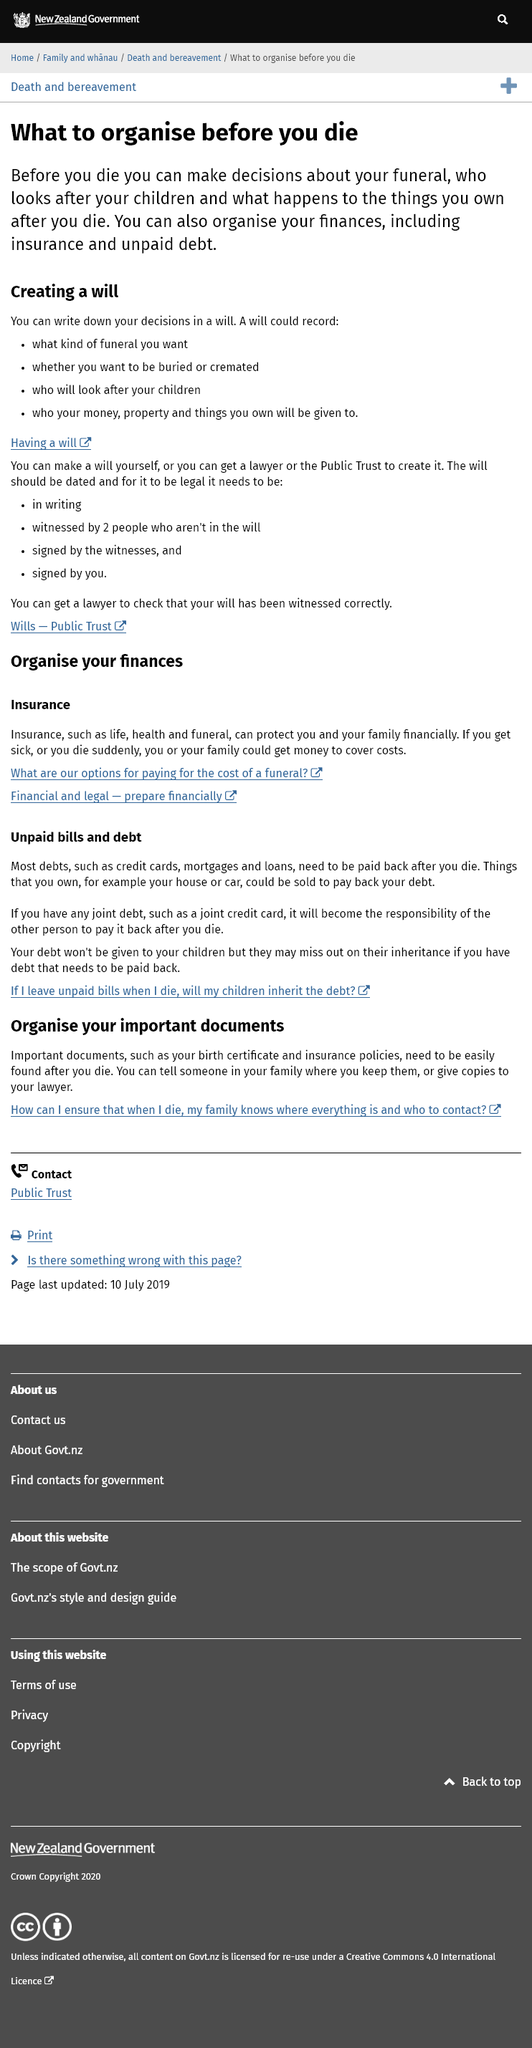Highlight a few significant elements in this photo. It is possible to make decisions regarding the care of one's children after death while still alive. A will can record the funeral preferences, the choice between burial or cremation, the designation of individuals who will care for children, and the distribution of assets, such as money, property, and personal belongings, to specified individuals or organizations. It is possible to organize one's finances, including insurance and unpaid debt, before passing away. 